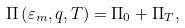<formula> <loc_0><loc_0><loc_500><loc_500>\Pi \left ( \varepsilon _ { m } , q , T \right ) = \Pi _ { 0 } + \Pi _ { T } ,</formula> 